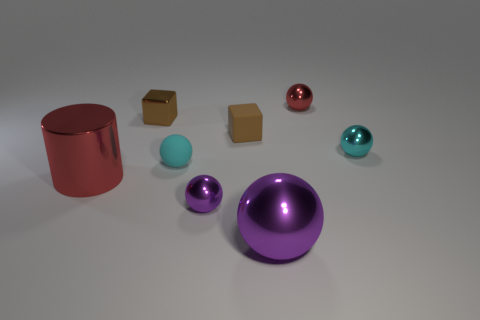There is a object that is the same color as the small rubber cube; what is its material?
Your answer should be very brief. Metal. How many cyan objects are there?
Provide a succinct answer. 2. Is there a cylinder made of the same material as the big purple ball?
Make the answer very short. Yes. Is the size of the cyan sphere on the left side of the red metal sphere the same as the red metal object that is behind the matte cube?
Provide a short and direct response. Yes. What is the size of the red object left of the tiny brown matte thing?
Offer a terse response. Large. Is there another small ball that has the same color as the matte sphere?
Your response must be concise. Yes. There is a tiny brown thing that is to the left of the tiny matte block; are there any balls that are in front of it?
Ensure brevity in your answer.  Yes. There is a cyan rubber sphere; does it have the same size as the cyan object that is behind the tiny cyan matte object?
Your answer should be very brief. Yes. There is a cyan object left of the large metal thing that is right of the matte sphere; are there any large purple objects that are behind it?
Give a very brief answer. No. There is a block to the right of the small purple ball; what material is it?
Your answer should be compact. Rubber. 